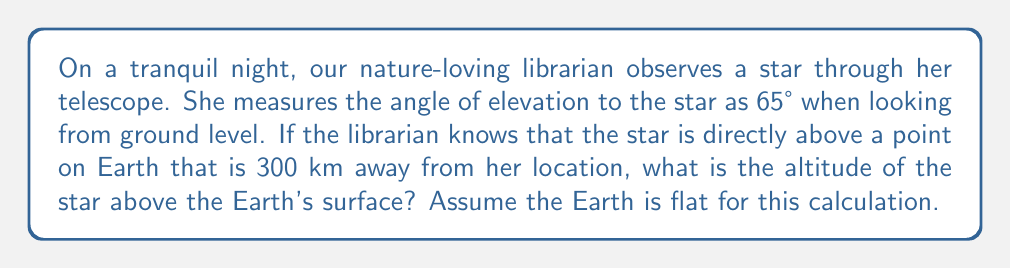Teach me how to tackle this problem. Let's approach this problem step-by-step using trigonometry:

1) First, let's visualize the scenario:

[asy]
import geometry;

size(200);
pair A = (0,0), B = (10,0), C = (10,20);
draw(A--B--C--A);
label("Librarian", A, SW);
label("300 km", (5,0), S);
label("Star", C, NE);
label("Altitude", (10,10), E);
label("65°", A, NE);
draw(A--(0,2), arrow=Arrow(TeXHead));
label("Ground level", (0,2), W);
[/asy]

2) We can see that this forms a right-angled triangle, where:
   - The base of the triangle is the distance along the ground (300 km)
   - The height of the triangle is the altitude of the star
   - The angle at the librarian's position is 65°

3) In this right-angled triangle, we know:
   - The adjacent side (base) = 300 km
   - The angle = 65°
   - We need to find the opposite side (altitude)

4) This scenario calls for the use of the tangent function. Recall that:

   $$\tan(\theta) = \frac{\text{opposite}}{\text{adjacent}}$$

5) Let's apply this to our problem:

   $$\tan(65°) = \frac{\text{altitude}}{300}$$

6) To solve for the altitude, we multiply both sides by 300:

   $$300 \cdot \tan(65°) = \text{altitude}$$

7) Now we can calculate:
   $$\text{altitude} = 300 \cdot \tan(65°) \approx 300 \cdot 2.1445 \approx 643.35 \text{ km}$$
Answer: The altitude of the star is approximately 643.35 km above the Earth's surface. 